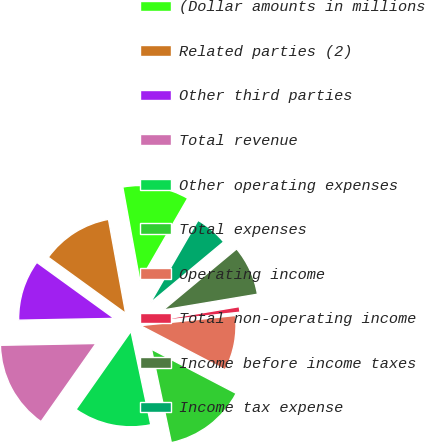<chart> <loc_0><loc_0><loc_500><loc_500><pie_chart><fcel>(Dollar amounts in millions<fcel>Related parties (2)<fcel>Other third parties<fcel>Total revenue<fcel>Other operating expenses<fcel>Total expenses<fcel>Operating income<fcel>Total non-operating income<fcel>Income before income taxes<fcel>Income tax expense<nl><fcel>11.21%<fcel>12.15%<fcel>10.28%<fcel>14.95%<fcel>13.08%<fcel>14.02%<fcel>9.35%<fcel>0.94%<fcel>8.41%<fcel>5.61%<nl></chart> 